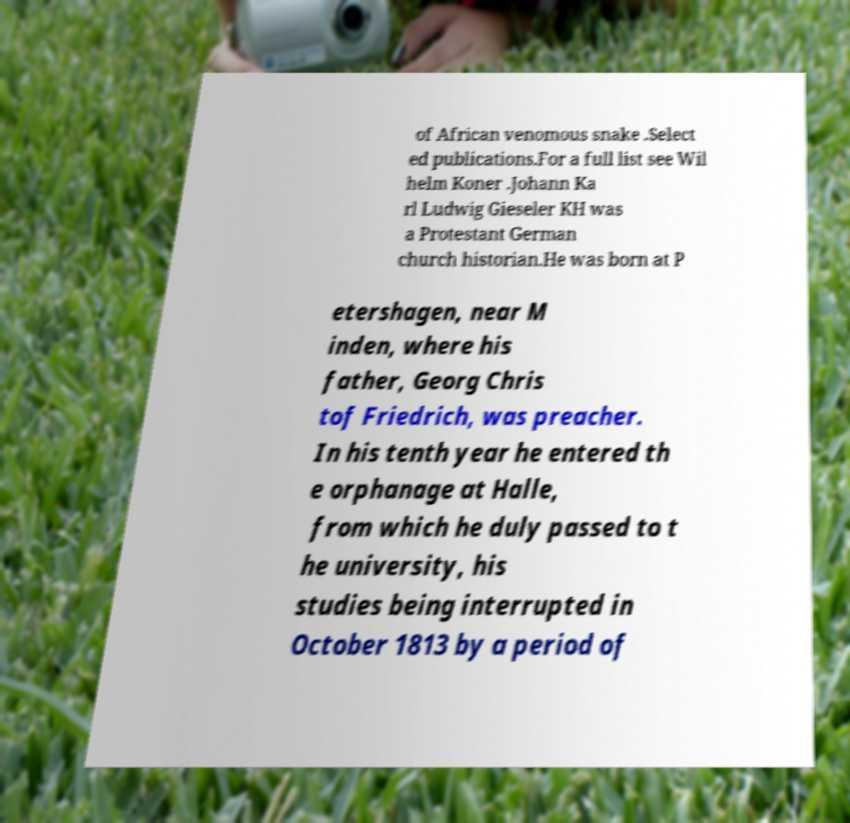I need the written content from this picture converted into text. Can you do that? of African venomous snake .Select ed publications.For a full list see Wil helm Koner .Johann Ka rl Ludwig Gieseler KH was a Protestant German church historian.He was born at P etershagen, near M inden, where his father, Georg Chris tof Friedrich, was preacher. In his tenth year he entered th e orphanage at Halle, from which he duly passed to t he university, his studies being interrupted in October 1813 by a period of 